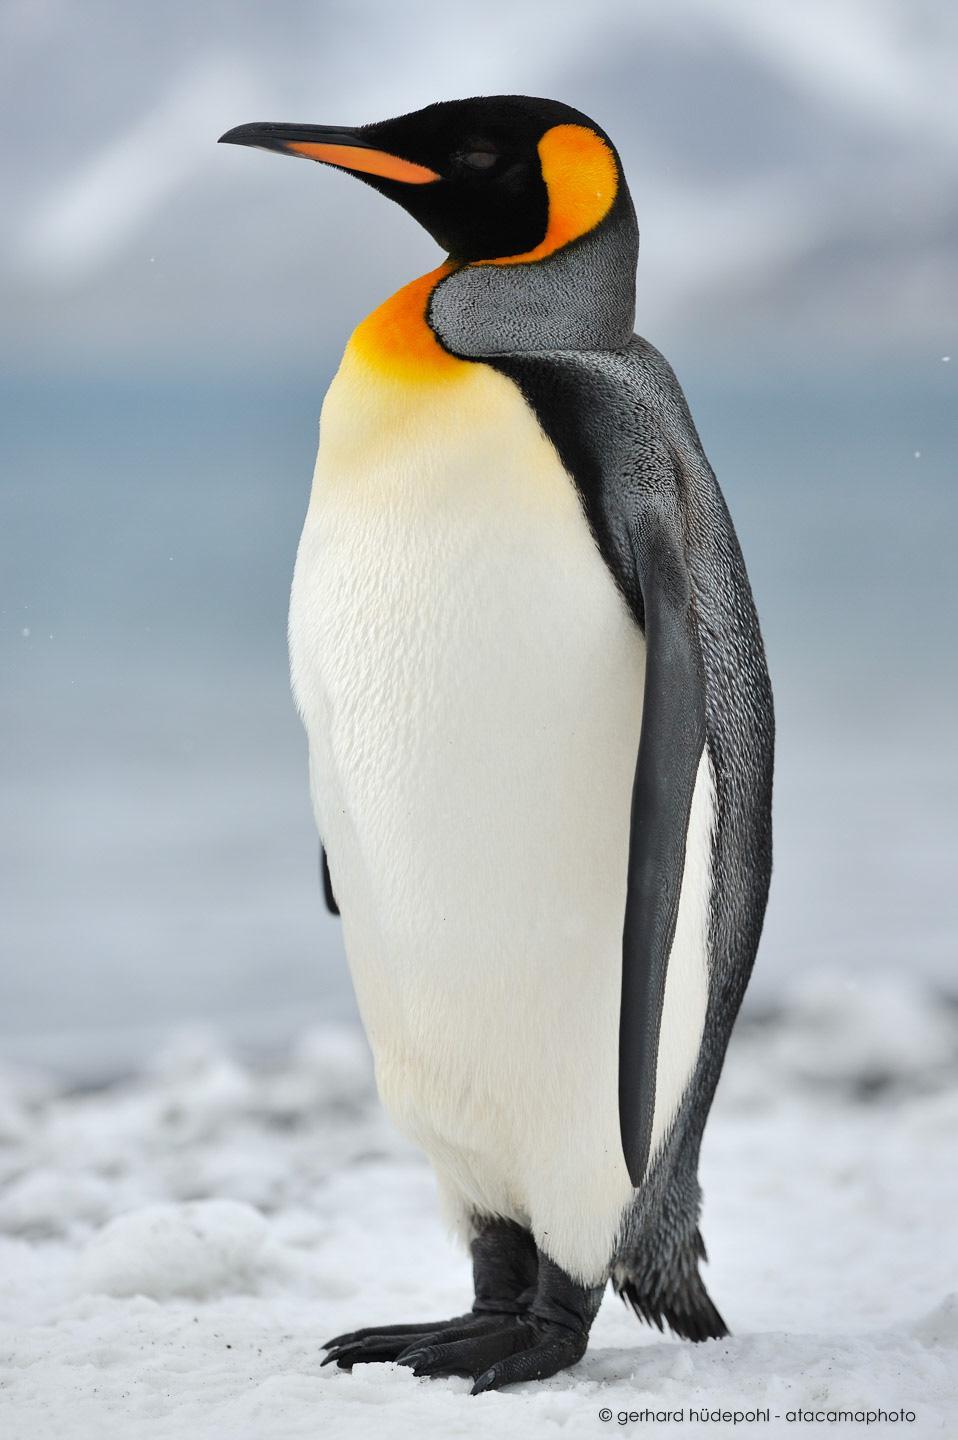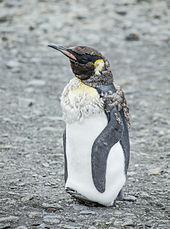The first image is the image on the left, the second image is the image on the right. Given the left and right images, does the statement "An image contains at least three penguins in the foreground, and all of them face in different directions." hold true? Answer yes or no. No. The first image is the image on the left, the second image is the image on the right. Examine the images to the left and right. Is the description "The right image contains no more than one penguin." accurate? Answer yes or no. Yes. 